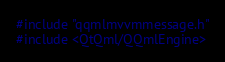Convert code to text. <code><loc_0><loc_0><loc_500><loc_500><_C++_>#include "qqmlmvvmmessage.h"
#include <QtQml/QQmlEngine></code> 